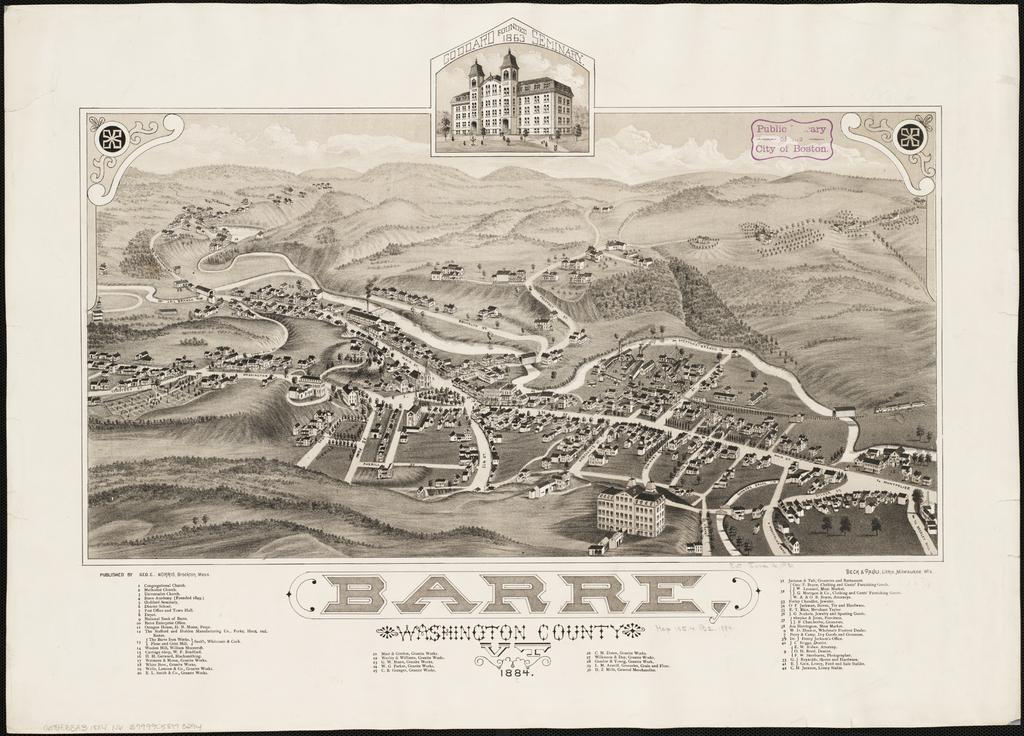<image>
Offer a succinct explanation of the picture presented. Poster that says the giant word "BARRE" on the bottom. 